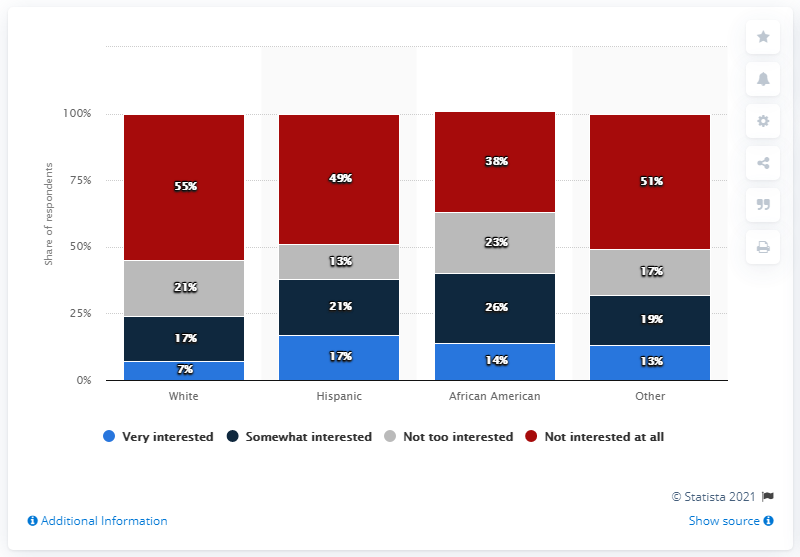Can you compare the level of interest in soccer between the White and Other categories? The image displays that 55% of respondents in the White category are very interested in soccer, which is a higher percentage compared to the 'Other' category at 51%. On the other hand, a smaller proportion of the White respondents are not interested at all (7%) compared to the Other category (13%). 